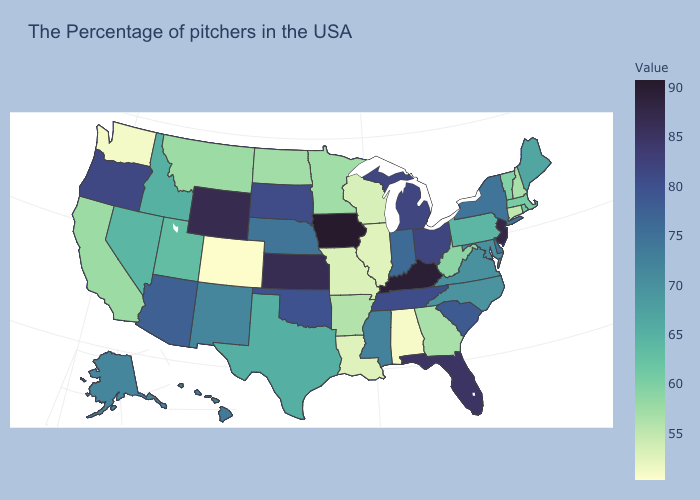Among the states that border California , which have the lowest value?
Short answer required. Nevada. Does New Mexico have a lower value than New Jersey?
Be succinct. Yes. Does Tennessee have the lowest value in the USA?
Quick response, please. No. Which states have the lowest value in the USA?
Be succinct. Colorado. Does Alabama have the highest value in the USA?
Keep it brief. No. Does Hawaii have the highest value in the USA?
Give a very brief answer. No. Does Colorado have the lowest value in the West?
Give a very brief answer. Yes. Which states hav the highest value in the MidWest?
Quick response, please. Iowa. 